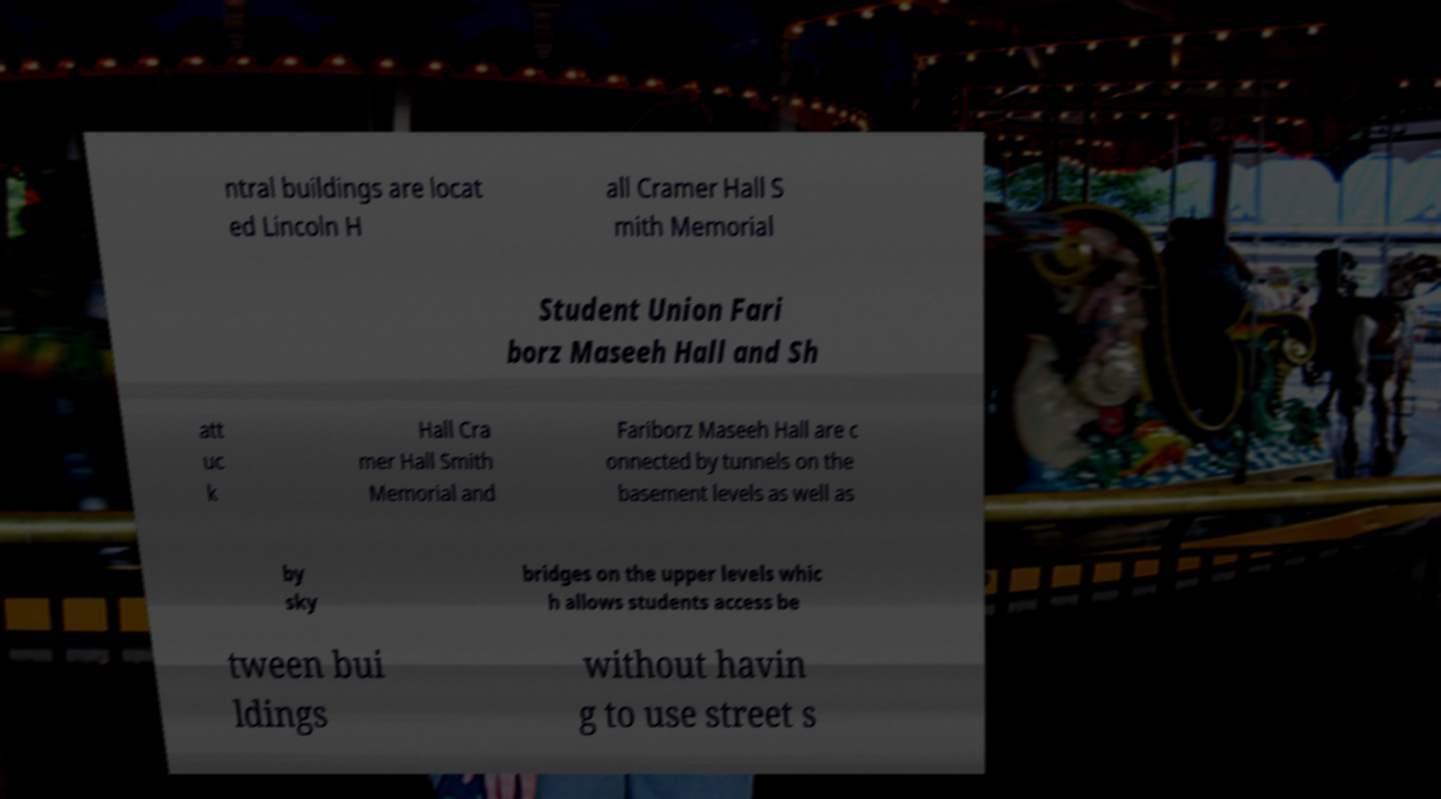For documentation purposes, I need the text within this image transcribed. Could you provide that? ntral buildings are locat ed Lincoln H all Cramer Hall S mith Memorial Student Union Fari borz Maseeh Hall and Sh att uc k Hall Cra mer Hall Smith Memorial and Fariborz Maseeh Hall are c onnected by tunnels on the basement levels as well as by sky bridges on the upper levels whic h allows students access be tween bui ldings without havin g to use street s 